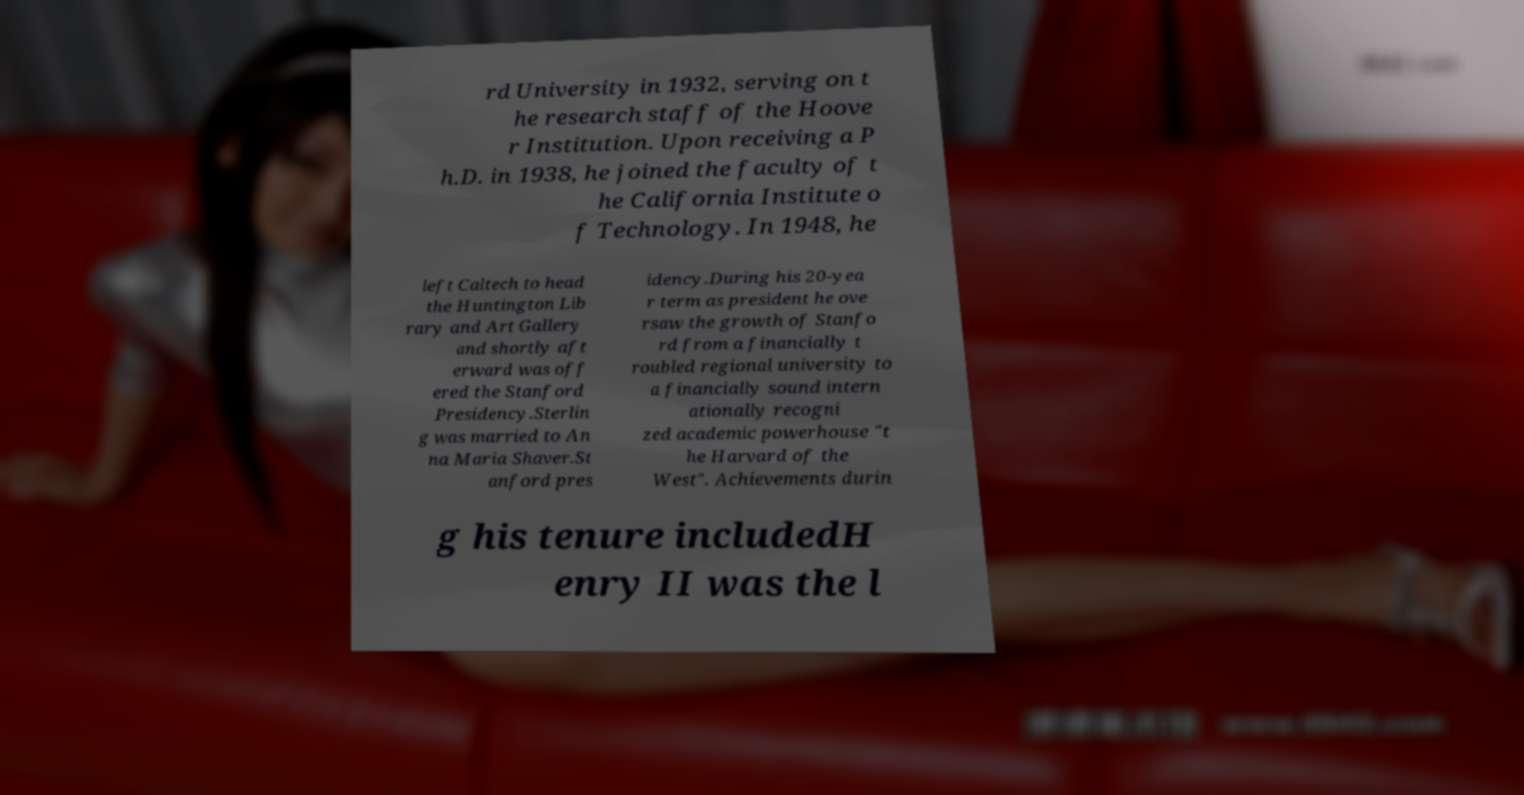I need the written content from this picture converted into text. Can you do that? rd University in 1932, serving on t he research staff of the Hoove r Institution. Upon receiving a P h.D. in 1938, he joined the faculty of t he California Institute o f Technology. In 1948, he left Caltech to head the Huntington Lib rary and Art Gallery and shortly aft erward was off ered the Stanford Presidency.Sterlin g was married to An na Maria Shaver.St anford pres idency.During his 20-yea r term as president he ove rsaw the growth of Stanfo rd from a financially t roubled regional university to a financially sound intern ationally recogni zed academic powerhouse "t he Harvard of the West". Achievements durin g his tenure includedH enry II was the l 